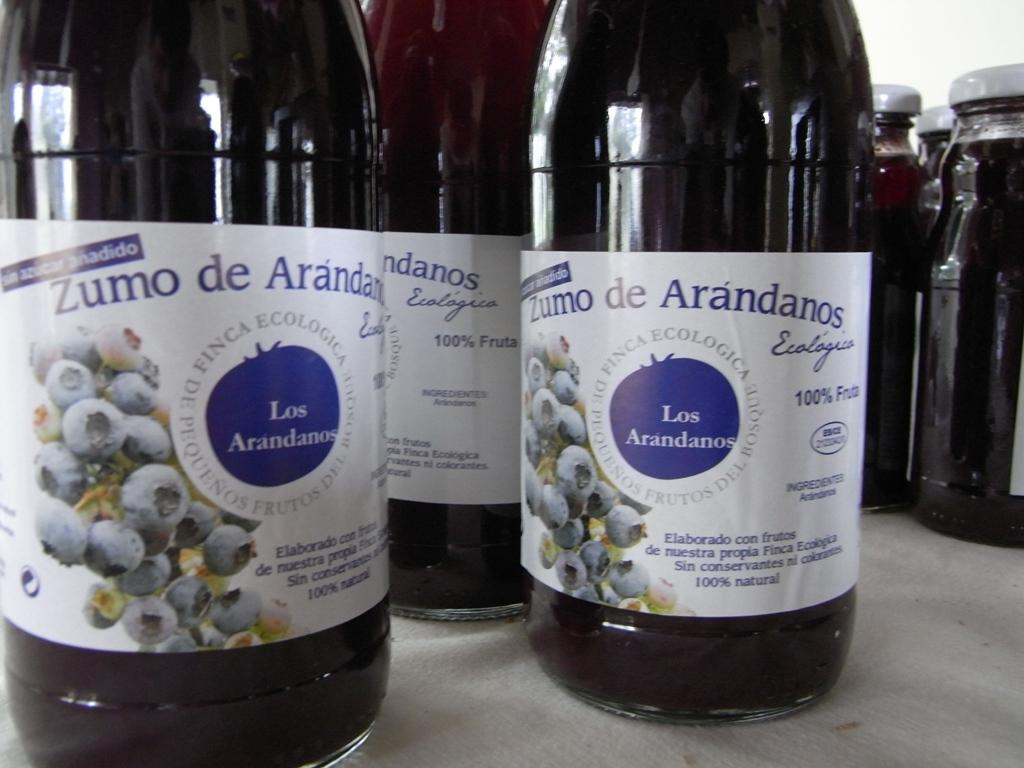<image>
Write a terse but informative summary of the picture. Bottles of Zumo de Arandanos are on a table. 